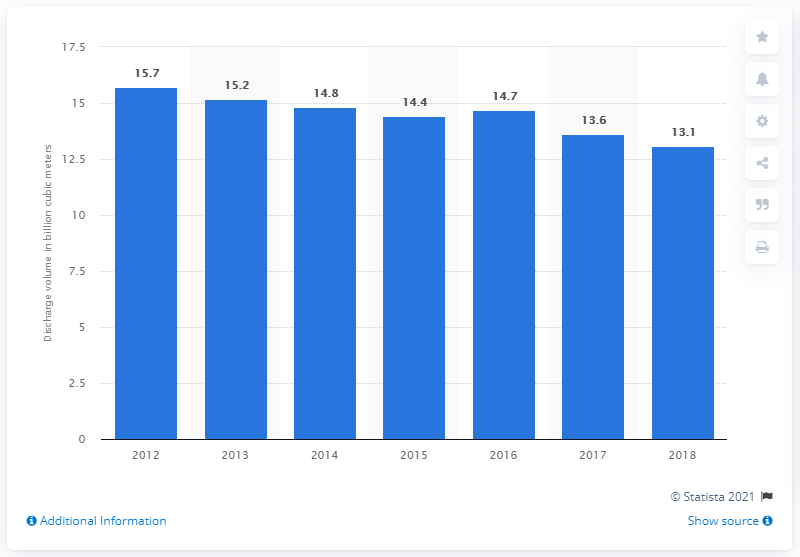List a handful of essential elements in this visual. In 2018, the volume of wastewater discharge in Russia was 13.1... 